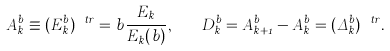<formula> <loc_0><loc_0><loc_500><loc_500>A ^ { b } _ { k } \equiv ( E ^ { b } _ { k } ) ^ { \ t r } = b \frac { E _ { k } } { E _ { k } ( b ) } , \quad D ^ { b } _ { k } = A ^ { b } _ { k + 1 } - A ^ { b } _ { k } = ( \Delta ^ { b } _ { k } ) ^ { \ t r } .</formula> 